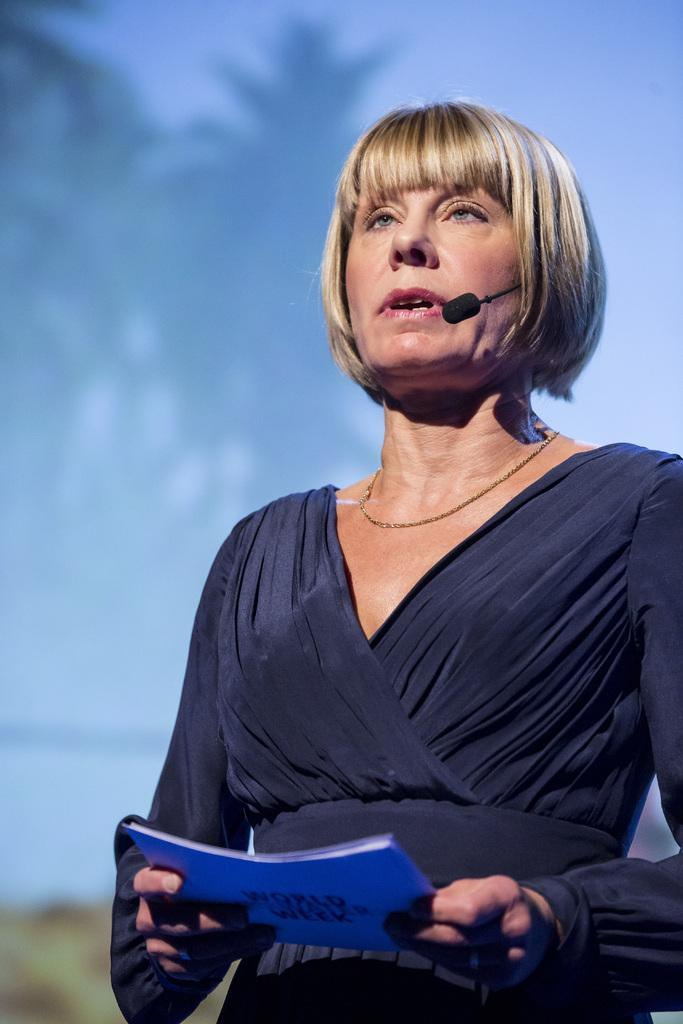Who is the main subject in the image? There is a woman in the image. What is the woman doing in the image? The woman is standing and appears to be talking. What is the woman holding in the image? The woman is holding a book. Can you describe the background of the image? The background of the image is not clear. What type of protest is happening in the background of the image? There is no protest visible in the image; the background is not clear. Can you tell me how many trucks are parked behind the woman in the image? There are no trucks present in the image; it only features the woman and a book. 